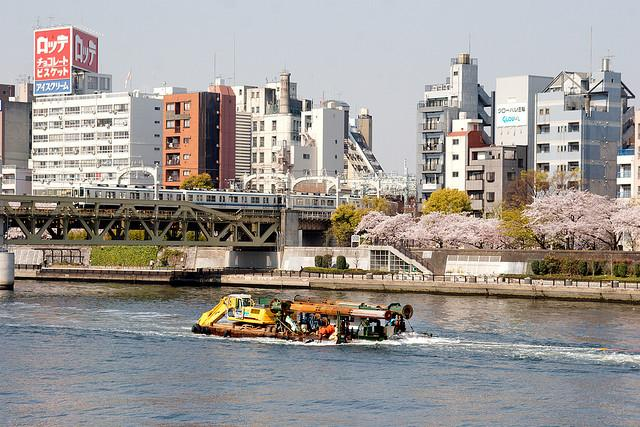What type of area is nearby? city 